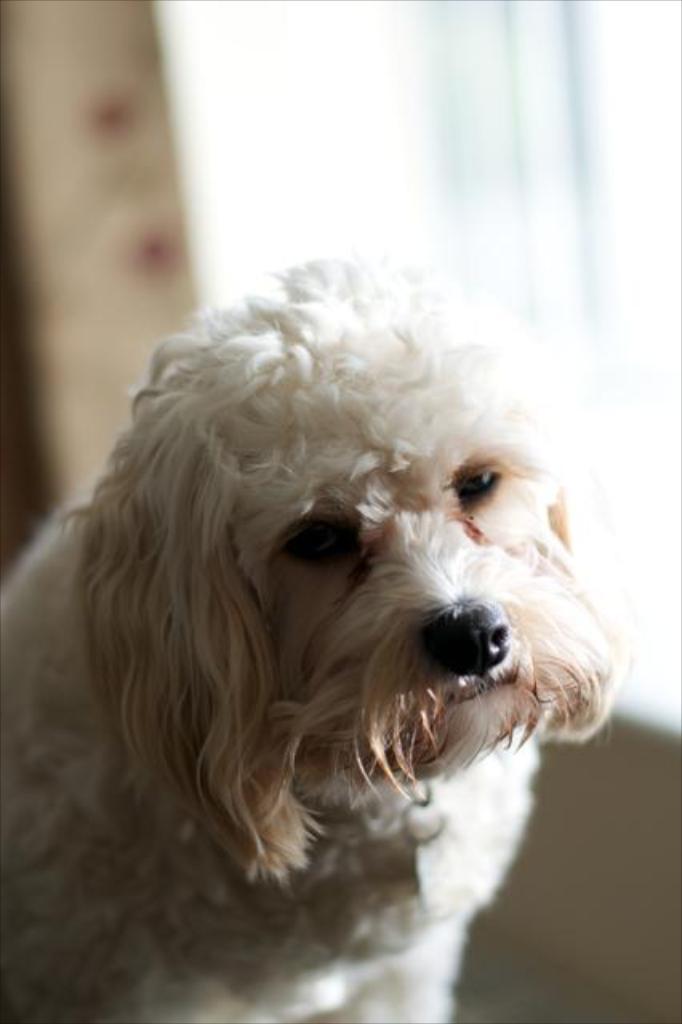In one or two sentences, can you explain what this image depicts? This is white color dog. 